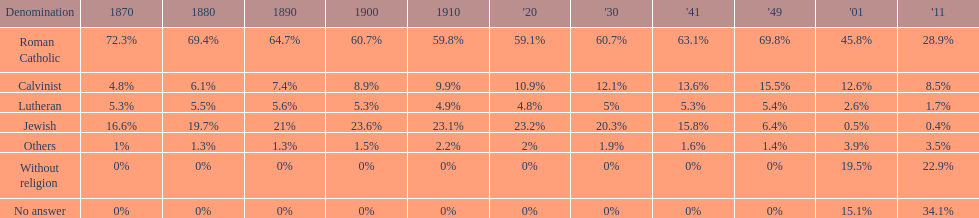What is the largest religious denomination in budapest? Roman Catholic. Help me parse the entirety of this table. {'header': ['Denomination', '1870', '1880', '1890', '1900', '1910', "'20", "'30", "'41", "'49", "'01", "'11"], 'rows': [['Roman Catholic', '72.3%', '69.4%', '64.7%', '60.7%', '59.8%', '59.1%', '60.7%', '63.1%', '69.8%', '45.8%', '28.9%'], ['Calvinist', '4.8%', '6.1%', '7.4%', '8.9%', '9.9%', '10.9%', '12.1%', '13.6%', '15.5%', '12.6%', '8.5%'], ['Lutheran', '5.3%', '5.5%', '5.6%', '5.3%', '4.9%', '4.8%', '5%', '5.3%', '5.4%', '2.6%', '1.7%'], ['Jewish', '16.6%', '19.7%', '21%', '23.6%', '23.1%', '23.2%', '20.3%', '15.8%', '6.4%', '0.5%', '0.4%'], ['Others', '1%', '1.3%', '1.3%', '1.5%', '2.2%', '2%', '1.9%', '1.6%', '1.4%', '3.9%', '3.5%'], ['Without religion', '0%', '0%', '0%', '0%', '0%', '0%', '0%', '0%', '0%', '19.5%', '22.9%'], ['No answer', '0%', '0%', '0%', '0%', '0%', '0%', '0%', '0%', '0%', '15.1%', '34.1%']]} 